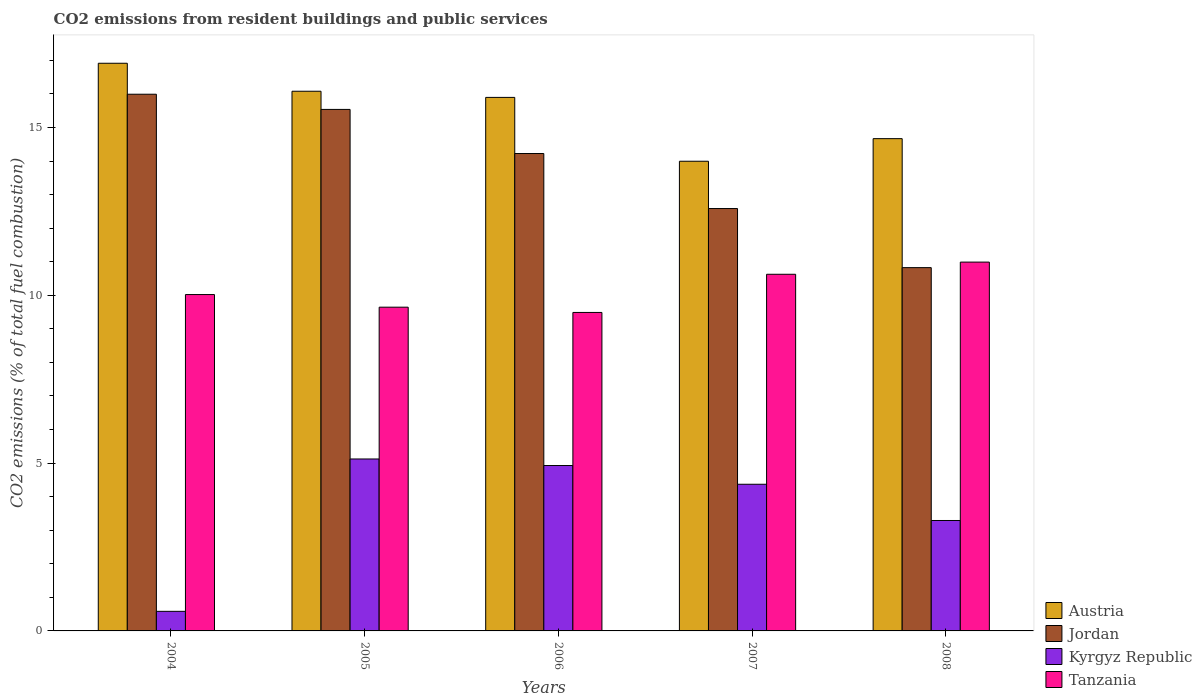How many groups of bars are there?
Keep it short and to the point. 5. How many bars are there on the 1st tick from the left?
Offer a very short reply. 4. How many bars are there on the 2nd tick from the right?
Keep it short and to the point. 4. What is the total CO2 emitted in Kyrgyz Republic in 2007?
Provide a succinct answer. 4.37. Across all years, what is the maximum total CO2 emitted in Kyrgyz Republic?
Make the answer very short. 5.12. Across all years, what is the minimum total CO2 emitted in Austria?
Your answer should be compact. 13.99. In which year was the total CO2 emitted in Kyrgyz Republic maximum?
Keep it short and to the point. 2005. In which year was the total CO2 emitted in Tanzania minimum?
Keep it short and to the point. 2006. What is the total total CO2 emitted in Kyrgyz Republic in the graph?
Give a very brief answer. 18.29. What is the difference between the total CO2 emitted in Austria in 2005 and that in 2007?
Make the answer very short. 2.09. What is the difference between the total CO2 emitted in Tanzania in 2007 and the total CO2 emitted in Austria in 2005?
Provide a succinct answer. -5.45. What is the average total CO2 emitted in Austria per year?
Provide a short and direct response. 15.51. In the year 2005, what is the difference between the total CO2 emitted in Jordan and total CO2 emitted in Tanzania?
Keep it short and to the point. 5.89. In how many years, is the total CO2 emitted in Jordan greater than 3?
Offer a terse response. 5. What is the ratio of the total CO2 emitted in Tanzania in 2004 to that in 2005?
Provide a short and direct response. 1.04. Is the total CO2 emitted in Jordan in 2004 less than that in 2006?
Your answer should be compact. No. Is the difference between the total CO2 emitted in Jordan in 2004 and 2008 greater than the difference between the total CO2 emitted in Tanzania in 2004 and 2008?
Your answer should be compact. Yes. What is the difference between the highest and the second highest total CO2 emitted in Tanzania?
Offer a very short reply. 0.36. What is the difference between the highest and the lowest total CO2 emitted in Tanzania?
Make the answer very short. 1.5. Is the sum of the total CO2 emitted in Jordan in 2005 and 2008 greater than the maximum total CO2 emitted in Tanzania across all years?
Ensure brevity in your answer.  Yes. Is it the case that in every year, the sum of the total CO2 emitted in Kyrgyz Republic and total CO2 emitted in Austria is greater than the sum of total CO2 emitted in Jordan and total CO2 emitted in Tanzania?
Your answer should be very brief. No. What does the 4th bar from the left in 2006 represents?
Give a very brief answer. Tanzania. What does the 2nd bar from the right in 2007 represents?
Provide a short and direct response. Kyrgyz Republic. Is it the case that in every year, the sum of the total CO2 emitted in Kyrgyz Republic and total CO2 emitted in Tanzania is greater than the total CO2 emitted in Austria?
Provide a succinct answer. No. How many bars are there?
Keep it short and to the point. 20. Are the values on the major ticks of Y-axis written in scientific E-notation?
Keep it short and to the point. No. Where does the legend appear in the graph?
Provide a succinct answer. Bottom right. What is the title of the graph?
Make the answer very short. CO2 emissions from resident buildings and public services. Does "Korea (Republic)" appear as one of the legend labels in the graph?
Your response must be concise. No. What is the label or title of the Y-axis?
Your answer should be compact. CO2 emissions (% of total fuel combustion). What is the CO2 emissions (% of total fuel combustion) in Austria in 2004?
Your answer should be compact. 16.91. What is the CO2 emissions (% of total fuel combustion) in Jordan in 2004?
Keep it short and to the point. 15.99. What is the CO2 emissions (% of total fuel combustion) in Kyrgyz Republic in 2004?
Provide a short and direct response. 0.58. What is the CO2 emissions (% of total fuel combustion) in Tanzania in 2004?
Provide a short and direct response. 10.02. What is the CO2 emissions (% of total fuel combustion) in Austria in 2005?
Offer a terse response. 16.08. What is the CO2 emissions (% of total fuel combustion) in Jordan in 2005?
Your answer should be compact. 15.54. What is the CO2 emissions (% of total fuel combustion) of Kyrgyz Republic in 2005?
Your answer should be compact. 5.12. What is the CO2 emissions (% of total fuel combustion) of Tanzania in 2005?
Offer a terse response. 9.65. What is the CO2 emissions (% of total fuel combustion) in Austria in 2006?
Make the answer very short. 15.9. What is the CO2 emissions (% of total fuel combustion) of Jordan in 2006?
Your answer should be compact. 14.22. What is the CO2 emissions (% of total fuel combustion) of Kyrgyz Republic in 2006?
Provide a succinct answer. 4.93. What is the CO2 emissions (% of total fuel combustion) in Tanzania in 2006?
Offer a very short reply. 9.49. What is the CO2 emissions (% of total fuel combustion) of Austria in 2007?
Keep it short and to the point. 13.99. What is the CO2 emissions (% of total fuel combustion) of Jordan in 2007?
Your answer should be very brief. 12.58. What is the CO2 emissions (% of total fuel combustion) of Kyrgyz Republic in 2007?
Ensure brevity in your answer.  4.37. What is the CO2 emissions (% of total fuel combustion) of Tanzania in 2007?
Your response must be concise. 10.63. What is the CO2 emissions (% of total fuel combustion) of Austria in 2008?
Give a very brief answer. 14.67. What is the CO2 emissions (% of total fuel combustion) of Jordan in 2008?
Provide a short and direct response. 10.82. What is the CO2 emissions (% of total fuel combustion) of Kyrgyz Republic in 2008?
Give a very brief answer. 3.29. What is the CO2 emissions (% of total fuel combustion) in Tanzania in 2008?
Provide a succinct answer. 10.99. Across all years, what is the maximum CO2 emissions (% of total fuel combustion) of Austria?
Your answer should be very brief. 16.91. Across all years, what is the maximum CO2 emissions (% of total fuel combustion) of Jordan?
Give a very brief answer. 15.99. Across all years, what is the maximum CO2 emissions (% of total fuel combustion) of Kyrgyz Republic?
Your answer should be compact. 5.12. Across all years, what is the maximum CO2 emissions (% of total fuel combustion) in Tanzania?
Your answer should be very brief. 10.99. Across all years, what is the minimum CO2 emissions (% of total fuel combustion) of Austria?
Give a very brief answer. 13.99. Across all years, what is the minimum CO2 emissions (% of total fuel combustion) of Jordan?
Keep it short and to the point. 10.82. Across all years, what is the minimum CO2 emissions (% of total fuel combustion) of Kyrgyz Republic?
Give a very brief answer. 0.58. Across all years, what is the minimum CO2 emissions (% of total fuel combustion) of Tanzania?
Your response must be concise. 9.49. What is the total CO2 emissions (% of total fuel combustion) in Austria in the graph?
Offer a very short reply. 77.55. What is the total CO2 emissions (% of total fuel combustion) of Jordan in the graph?
Keep it short and to the point. 69.16. What is the total CO2 emissions (% of total fuel combustion) in Kyrgyz Republic in the graph?
Make the answer very short. 18.29. What is the total CO2 emissions (% of total fuel combustion) in Tanzania in the graph?
Your answer should be very brief. 50.77. What is the difference between the CO2 emissions (% of total fuel combustion) in Austria in 2004 and that in 2005?
Offer a very short reply. 0.83. What is the difference between the CO2 emissions (% of total fuel combustion) in Jordan in 2004 and that in 2005?
Your answer should be compact. 0.45. What is the difference between the CO2 emissions (% of total fuel combustion) in Kyrgyz Republic in 2004 and that in 2005?
Your answer should be very brief. -4.54. What is the difference between the CO2 emissions (% of total fuel combustion) in Tanzania in 2004 and that in 2005?
Keep it short and to the point. 0.38. What is the difference between the CO2 emissions (% of total fuel combustion) of Austria in 2004 and that in 2006?
Your response must be concise. 1.02. What is the difference between the CO2 emissions (% of total fuel combustion) of Jordan in 2004 and that in 2006?
Your answer should be compact. 1.77. What is the difference between the CO2 emissions (% of total fuel combustion) in Kyrgyz Republic in 2004 and that in 2006?
Offer a terse response. -4.34. What is the difference between the CO2 emissions (% of total fuel combustion) of Tanzania in 2004 and that in 2006?
Make the answer very short. 0.53. What is the difference between the CO2 emissions (% of total fuel combustion) of Austria in 2004 and that in 2007?
Your response must be concise. 2.92. What is the difference between the CO2 emissions (% of total fuel combustion) of Jordan in 2004 and that in 2007?
Give a very brief answer. 3.41. What is the difference between the CO2 emissions (% of total fuel combustion) of Kyrgyz Republic in 2004 and that in 2007?
Ensure brevity in your answer.  -3.79. What is the difference between the CO2 emissions (% of total fuel combustion) in Tanzania in 2004 and that in 2007?
Provide a succinct answer. -0.6. What is the difference between the CO2 emissions (% of total fuel combustion) in Austria in 2004 and that in 2008?
Your response must be concise. 2.25. What is the difference between the CO2 emissions (% of total fuel combustion) of Jordan in 2004 and that in 2008?
Your answer should be very brief. 5.17. What is the difference between the CO2 emissions (% of total fuel combustion) in Kyrgyz Republic in 2004 and that in 2008?
Keep it short and to the point. -2.71. What is the difference between the CO2 emissions (% of total fuel combustion) in Tanzania in 2004 and that in 2008?
Your answer should be very brief. -0.97. What is the difference between the CO2 emissions (% of total fuel combustion) in Austria in 2005 and that in 2006?
Make the answer very short. 0.18. What is the difference between the CO2 emissions (% of total fuel combustion) of Jordan in 2005 and that in 2006?
Provide a succinct answer. 1.31. What is the difference between the CO2 emissions (% of total fuel combustion) in Kyrgyz Republic in 2005 and that in 2006?
Provide a succinct answer. 0.19. What is the difference between the CO2 emissions (% of total fuel combustion) of Tanzania in 2005 and that in 2006?
Keep it short and to the point. 0.16. What is the difference between the CO2 emissions (% of total fuel combustion) of Austria in 2005 and that in 2007?
Your answer should be compact. 2.09. What is the difference between the CO2 emissions (% of total fuel combustion) in Jordan in 2005 and that in 2007?
Your answer should be very brief. 2.95. What is the difference between the CO2 emissions (% of total fuel combustion) of Kyrgyz Republic in 2005 and that in 2007?
Provide a succinct answer. 0.75. What is the difference between the CO2 emissions (% of total fuel combustion) in Tanzania in 2005 and that in 2007?
Your answer should be compact. -0.98. What is the difference between the CO2 emissions (% of total fuel combustion) in Austria in 2005 and that in 2008?
Your answer should be compact. 1.41. What is the difference between the CO2 emissions (% of total fuel combustion) in Jordan in 2005 and that in 2008?
Make the answer very short. 4.71. What is the difference between the CO2 emissions (% of total fuel combustion) in Kyrgyz Republic in 2005 and that in 2008?
Provide a succinct answer. 1.83. What is the difference between the CO2 emissions (% of total fuel combustion) of Tanzania in 2005 and that in 2008?
Your answer should be very brief. -1.34. What is the difference between the CO2 emissions (% of total fuel combustion) in Austria in 2006 and that in 2007?
Provide a succinct answer. 1.9. What is the difference between the CO2 emissions (% of total fuel combustion) of Jordan in 2006 and that in 2007?
Make the answer very short. 1.64. What is the difference between the CO2 emissions (% of total fuel combustion) in Kyrgyz Republic in 2006 and that in 2007?
Your answer should be compact. 0.56. What is the difference between the CO2 emissions (% of total fuel combustion) of Tanzania in 2006 and that in 2007?
Give a very brief answer. -1.14. What is the difference between the CO2 emissions (% of total fuel combustion) in Austria in 2006 and that in 2008?
Your response must be concise. 1.23. What is the difference between the CO2 emissions (% of total fuel combustion) in Jordan in 2006 and that in 2008?
Provide a short and direct response. 3.4. What is the difference between the CO2 emissions (% of total fuel combustion) in Kyrgyz Republic in 2006 and that in 2008?
Your response must be concise. 1.64. What is the difference between the CO2 emissions (% of total fuel combustion) of Tanzania in 2006 and that in 2008?
Offer a very short reply. -1.5. What is the difference between the CO2 emissions (% of total fuel combustion) of Austria in 2007 and that in 2008?
Give a very brief answer. -0.67. What is the difference between the CO2 emissions (% of total fuel combustion) in Jordan in 2007 and that in 2008?
Make the answer very short. 1.76. What is the difference between the CO2 emissions (% of total fuel combustion) in Kyrgyz Republic in 2007 and that in 2008?
Ensure brevity in your answer.  1.08. What is the difference between the CO2 emissions (% of total fuel combustion) of Tanzania in 2007 and that in 2008?
Ensure brevity in your answer.  -0.36. What is the difference between the CO2 emissions (% of total fuel combustion) of Austria in 2004 and the CO2 emissions (% of total fuel combustion) of Jordan in 2005?
Offer a very short reply. 1.38. What is the difference between the CO2 emissions (% of total fuel combustion) of Austria in 2004 and the CO2 emissions (% of total fuel combustion) of Kyrgyz Republic in 2005?
Ensure brevity in your answer.  11.79. What is the difference between the CO2 emissions (% of total fuel combustion) in Austria in 2004 and the CO2 emissions (% of total fuel combustion) in Tanzania in 2005?
Give a very brief answer. 7.27. What is the difference between the CO2 emissions (% of total fuel combustion) of Jordan in 2004 and the CO2 emissions (% of total fuel combustion) of Kyrgyz Republic in 2005?
Keep it short and to the point. 10.87. What is the difference between the CO2 emissions (% of total fuel combustion) in Jordan in 2004 and the CO2 emissions (% of total fuel combustion) in Tanzania in 2005?
Offer a very short reply. 6.34. What is the difference between the CO2 emissions (% of total fuel combustion) of Kyrgyz Republic in 2004 and the CO2 emissions (% of total fuel combustion) of Tanzania in 2005?
Offer a very short reply. -9.06. What is the difference between the CO2 emissions (% of total fuel combustion) in Austria in 2004 and the CO2 emissions (% of total fuel combustion) in Jordan in 2006?
Offer a terse response. 2.69. What is the difference between the CO2 emissions (% of total fuel combustion) of Austria in 2004 and the CO2 emissions (% of total fuel combustion) of Kyrgyz Republic in 2006?
Keep it short and to the point. 11.99. What is the difference between the CO2 emissions (% of total fuel combustion) of Austria in 2004 and the CO2 emissions (% of total fuel combustion) of Tanzania in 2006?
Keep it short and to the point. 7.42. What is the difference between the CO2 emissions (% of total fuel combustion) of Jordan in 2004 and the CO2 emissions (% of total fuel combustion) of Kyrgyz Republic in 2006?
Your answer should be compact. 11.06. What is the difference between the CO2 emissions (% of total fuel combustion) in Jordan in 2004 and the CO2 emissions (% of total fuel combustion) in Tanzania in 2006?
Keep it short and to the point. 6.5. What is the difference between the CO2 emissions (% of total fuel combustion) in Kyrgyz Republic in 2004 and the CO2 emissions (% of total fuel combustion) in Tanzania in 2006?
Give a very brief answer. -8.91. What is the difference between the CO2 emissions (% of total fuel combustion) in Austria in 2004 and the CO2 emissions (% of total fuel combustion) in Jordan in 2007?
Make the answer very short. 4.33. What is the difference between the CO2 emissions (% of total fuel combustion) of Austria in 2004 and the CO2 emissions (% of total fuel combustion) of Kyrgyz Republic in 2007?
Your answer should be very brief. 12.54. What is the difference between the CO2 emissions (% of total fuel combustion) of Austria in 2004 and the CO2 emissions (% of total fuel combustion) of Tanzania in 2007?
Make the answer very short. 6.29. What is the difference between the CO2 emissions (% of total fuel combustion) of Jordan in 2004 and the CO2 emissions (% of total fuel combustion) of Kyrgyz Republic in 2007?
Give a very brief answer. 11.62. What is the difference between the CO2 emissions (% of total fuel combustion) of Jordan in 2004 and the CO2 emissions (% of total fuel combustion) of Tanzania in 2007?
Your answer should be compact. 5.36. What is the difference between the CO2 emissions (% of total fuel combustion) in Kyrgyz Republic in 2004 and the CO2 emissions (% of total fuel combustion) in Tanzania in 2007?
Provide a short and direct response. -10.04. What is the difference between the CO2 emissions (% of total fuel combustion) of Austria in 2004 and the CO2 emissions (% of total fuel combustion) of Jordan in 2008?
Ensure brevity in your answer.  6.09. What is the difference between the CO2 emissions (% of total fuel combustion) in Austria in 2004 and the CO2 emissions (% of total fuel combustion) in Kyrgyz Republic in 2008?
Give a very brief answer. 13.62. What is the difference between the CO2 emissions (% of total fuel combustion) in Austria in 2004 and the CO2 emissions (% of total fuel combustion) in Tanzania in 2008?
Provide a succinct answer. 5.92. What is the difference between the CO2 emissions (% of total fuel combustion) in Jordan in 2004 and the CO2 emissions (% of total fuel combustion) in Kyrgyz Republic in 2008?
Ensure brevity in your answer.  12.7. What is the difference between the CO2 emissions (% of total fuel combustion) in Jordan in 2004 and the CO2 emissions (% of total fuel combustion) in Tanzania in 2008?
Your response must be concise. 5. What is the difference between the CO2 emissions (% of total fuel combustion) in Kyrgyz Republic in 2004 and the CO2 emissions (% of total fuel combustion) in Tanzania in 2008?
Keep it short and to the point. -10.41. What is the difference between the CO2 emissions (% of total fuel combustion) in Austria in 2005 and the CO2 emissions (% of total fuel combustion) in Jordan in 2006?
Offer a very short reply. 1.86. What is the difference between the CO2 emissions (% of total fuel combustion) of Austria in 2005 and the CO2 emissions (% of total fuel combustion) of Kyrgyz Republic in 2006?
Make the answer very short. 11.15. What is the difference between the CO2 emissions (% of total fuel combustion) of Austria in 2005 and the CO2 emissions (% of total fuel combustion) of Tanzania in 2006?
Keep it short and to the point. 6.59. What is the difference between the CO2 emissions (% of total fuel combustion) of Jordan in 2005 and the CO2 emissions (% of total fuel combustion) of Kyrgyz Republic in 2006?
Your answer should be compact. 10.61. What is the difference between the CO2 emissions (% of total fuel combustion) in Jordan in 2005 and the CO2 emissions (% of total fuel combustion) in Tanzania in 2006?
Offer a terse response. 6.05. What is the difference between the CO2 emissions (% of total fuel combustion) of Kyrgyz Republic in 2005 and the CO2 emissions (% of total fuel combustion) of Tanzania in 2006?
Ensure brevity in your answer.  -4.37. What is the difference between the CO2 emissions (% of total fuel combustion) of Austria in 2005 and the CO2 emissions (% of total fuel combustion) of Jordan in 2007?
Ensure brevity in your answer.  3.49. What is the difference between the CO2 emissions (% of total fuel combustion) of Austria in 2005 and the CO2 emissions (% of total fuel combustion) of Kyrgyz Republic in 2007?
Provide a succinct answer. 11.71. What is the difference between the CO2 emissions (% of total fuel combustion) in Austria in 2005 and the CO2 emissions (% of total fuel combustion) in Tanzania in 2007?
Give a very brief answer. 5.45. What is the difference between the CO2 emissions (% of total fuel combustion) of Jordan in 2005 and the CO2 emissions (% of total fuel combustion) of Kyrgyz Republic in 2007?
Ensure brevity in your answer.  11.17. What is the difference between the CO2 emissions (% of total fuel combustion) of Jordan in 2005 and the CO2 emissions (% of total fuel combustion) of Tanzania in 2007?
Make the answer very short. 4.91. What is the difference between the CO2 emissions (% of total fuel combustion) in Kyrgyz Republic in 2005 and the CO2 emissions (% of total fuel combustion) in Tanzania in 2007?
Your answer should be compact. -5.5. What is the difference between the CO2 emissions (% of total fuel combustion) of Austria in 2005 and the CO2 emissions (% of total fuel combustion) of Jordan in 2008?
Offer a terse response. 5.26. What is the difference between the CO2 emissions (% of total fuel combustion) in Austria in 2005 and the CO2 emissions (% of total fuel combustion) in Kyrgyz Republic in 2008?
Provide a short and direct response. 12.79. What is the difference between the CO2 emissions (% of total fuel combustion) in Austria in 2005 and the CO2 emissions (% of total fuel combustion) in Tanzania in 2008?
Make the answer very short. 5.09. What is the difference between the CO2 emissions (% of total fuel combustion) in Jordan in 2005 and the CO2 emissions (% of total fuel combustion) in Kyrgyz Republic in 2008?
Offer a very short reply. 12.25. What is the difference between the CO2 emissions (% of total fuel combustion) in Jordan in 2005 and the CO2 emissions (% of total fuel combustion) in Tanzania in 2008?
Keep it short and to the point. 4.55. What is the difference between the CO2 emissions (% of total fuel combustion) in Kyrgyz Republic in 2005 and the CO2 emissions (% of total fuel combustion) in Tanzania in 2008?
Make the answer very short. -5.87. What is the difference between the CO2 emissions (% of total fuel combustion) of Austria in 2006 and the CO2 emissions (% of total fuel combustion) of Jordan in 2007?
Keep it short and to the point. 3.31. What is the difference between the CO2 emissions (% of total fuel combustion) of Austria in 2006 and the CO2 emissions (% of total fuel combustion) of Kyrgyz Republic in 2007?
Provide a short and direct response. 11.53. What is the difference between the CO2 emissions (% of total fuel combustion) in Austria in 2006 and the CO2 emissions (% of total fuel combustion) in Tanzania in 2007?
Ensure brevity in your answer.  5.27. What is the difference between the CO2 emissions (% of total fuel combustion) of Jordan in 2006 and the CO2 emissions (% of total fuel combustion) of Kyrgyz Republic in 2007?
Offer a very short reply. 9.85. What is the difference between the CO2 emissions (% of total fuel combustion) in Jordan in 2006 and the CO2 emissions (% of total fuel combustion) in Tanzania in 2007?
Offer a terse response. 3.6. What is the difference between the CO2 emissions (% of total fuel combustion) in Kyrgyz Republic in 2006 and the CO2 emissions (% of total fuel combustion) in Tanzania in 2007?
Provide a short and direct response. -5.7. What is the difference between the CO2 emissions (% of total fuel combustion) of Austria in 2006 and the CO2 emissions (% of total fuel combustion) of Jordan in 2008?
Your response must be concise. 5.07. What is the difference between the CO2 emissions (% of total fuel combustion) of Austria in 2006 and the CO2 emissions (% of total fuel combustion) of Kyrgyz Republic in 2008?
Ensure brevity in your answer.  12.61. What is the difference between the CO2 emissions (% of total fuel combustion) of Austria in 2006 and the CO2 emissions (% of total fuel combustion) of Tanzania in 2008?
Your answer should be very brief. 4.91. What is the difference between the CO2 emissions (% of total fuel combustion) of Jordan in 2006 and the CO2 emissions (% of total fuel combustion) of Kyrgyz Republic in 2008?
Offer a terse response. 10.93. What is the difference between the CO2 emissions (% of total fuel combustion) of Jordan in 2006 and the CO2 emissions (% of total fuel combustion) of Tanzania in 2008?
Your response must be concise. 3.23. What is the difference between the CO2 emissions (% of total fuel combustion) of Kyrgyz Republic in 2006 and the CO2 emissions (% of total fuel combustion) of Tanzania in 2008?
Keep it short and to the point. -6.06. What is the difference between the CO2 emissions (% of total fuel combustion) in Austria in 2007 and the CO2 emissions (% of total fuel combustion) in Jordan in 2008?
Ensure brevity in your answer.  3.17. What is the difference between the CO2 emissions (% of total fuel combustion) of Austria in 2007 and the CO2 emissions (% of total fuel combustion) of Kyrgyz Republic in 2008?
Offer a very short reply. 10.7. What is the difference between the CO2 emissions (% of total fuel combustion) in Austria in 2007 and the CO2 emissions (% of total fuel combustion) in Tanzania in 2008?
Your response must be concise. 3. What is the difference between the CO2 emissions (% of total fuel combustion) of Jordan in 2007 and the CO2 emissions (% of total fuel combustion) of Kyrgyz Republic in 2008?
Give a very brief answer. 9.29. What is the difference between the CO2 emissions (% of total fuel combustion) of Jordan in 2007 and the CO2 emissions (% of total fuel combustion) of Tanzania in 2008?
Offer a very short reply. 1.6. What is the difference between the CO2 emissions (% of total fuel combustion) of Kyrgyz Republic in 2007 and the CO2 emissions (% of total fuel combustion) of Tanzania in 2008?
Your answer should be very brief. -6.62. What is the average CO2 emissions (% of total fuel combustion) of Austria per year?
Make the answer very short. 15.51. What is the average CO2 emissions (% of total fuel combustion) of Jordan per year?
Give a very brief answer. 13.83. What is the average CO2 emissions (% of total fuel combustion) in Kyrgyz Republic per year?
Provide a short and direct response. 3.66. What is the average CO2 emissions (% of total fuel combustion) in Tanzania per year?
Provide a short and direct response. 10.15. In the year 2004, what is the difference between the CO2 emissions (% of total fuel combustion) of Austria and CO2 emissions (% of total fuel combustion) of Jordan?
Offer a terse response. 0.92. In the year 2004, what is the difference between the CO2 emissions (% of total fuel combustion) of Austria and CO2 emissions (% of total fuel combustion) of Kyrgyz Republic?
Offer a terse response. 16.33. In the year 2004, what is the difference between the CO2 emissions (% of total fuel combustion) of Austria and CO2 emissions (% of total fuel combustion) of Tanzania?
Make the answer very short. 6.89. In the year 2004, what is the difference between the CO2 emissions (% of total fuel combustion) of Jordan and CO2 emissions (% of total fuel combustion) of Kyrgyz Republic?
Your response must be concise. 15.41. In the year 2004, what is the difference between the CO2 emissions (% of total fuel combustion) of Jordan and CO2 emissions (% of total fuel combustion) of Tanzania?
Make the answer very short. 5.97. In the year 2004, what is the difference between the CO2 emissions (% of total fuel combustion) in Kyrgyz Republic and CO2 emissions (% of total fuel combustion) in Tanzania?
Provide a short and direct response. -9.44. In the year 2005, what is the difference between the CO2 emissions (% of total fuel combustion) in Austria and CO2 emissions (% of total fuel combustion) in Jordan?
Give a very brief answer. 0.54. In the year 2005, what is the difference between the CO2 emissions (% of total fuel combustion) in Austria and CO2 emissions (% of total fuel combustion) in Kyrgyz Republic?
Offer a terse response. 10.96. In the year 2005, what is the difference between the CO2 emissions (% of total fuel combustion) in Austria and CO2 emissions (% of total fuel combustion) in Tanzania?
Offer a very short reply. 6.43. In the year 2005, what is the difference between the CO2 emissions (% of total fuel combustion) in Jordan and CO2 emissions (% of total fuel combustion) in Kyrgyz Republic?
Give a very brief answer. 10.42. In the year 2005, what is the difference between the CO2 emissions (% of total fuel combustion) in Jordan and CO2 emissions (% of total fuel combustion) in Tanzania?
Provide a short and direct response. 5.89. In the year 2005, what is the difference between the CO2 emissions (% of total fuel combustion) of Kyrgyz Republic and CO2 emissions (% of total fuel combustion) of Tanzania?
Give a very brief answer. -4.52. In the year 2006, what is the difference between the CO2 emissions (% of total fuel combustion) in Austria and CO2 emissions (% of total fuel combustion) in Jordan?
Provide a succinct answer. 1.67. In the year 2006, what is the difference between the CO2 emissions (% of total fuel combustion) of Austria and CO2 emissions (% of total fuel combustion) of Kyrgyz Republic?
Offer a very short reply. 10.97. In the year 2006, what is the difference between the CO2 emissions (% of total fuel combustion) of Austria and CO2 emissions (% of total fuel combustion) of Tanzania?
Your answer should be very brief. 6.41. In the year 2006, what is the difference between the CO2 emissions (% of total fuel combustion) in Jordan and CO2 emissions (% of total fuel combustion) in Kyrgyz Republic?
Make the answer very short. 9.3. In the year 2006, what is the difference between the CO2 emissions (% of total fuel combustion) of Jordan and CO2 emissions (% of total fuel combustion) of Tanzania?
Offer a very short reply. 4.73. In the year 2006, what is the difference between the CO2 emissions (% of total fuel combustion) in Kyrgyz Republic and CO2 emissions (% of total fuel combustion) in Tanzania?
Your answer should be very brief. -4.56. In the year 2007, what is the difference between the CO2 emissions (% of total fuel combustion) of Austria and CO2 emissions (% of total fuel combustion) of Jordan?
Offer a very short reply. 1.41. In the year 2007, what is the difference between the CO2 emissions (% of total fuel combustion) of Austria and CO2 emissions (% of total fuel combustion) of Kyrgyz Republic?
Offer a terse response. 9.62. In the year 2007, what is the difference between the CO2 emissions (% of total fuel combustion) in Austria and CO2 emissions (% of total fuel combustion) in Tanzania?
Your answer should be very brief. 3.37. In the year 2007, what is the difference between the CO2 emissions (% of total fuel combustion) in Jordan and CO2 emissions (% of total fuel combustion) in Kyrgyz Republic?
Your answer should be compact. 8.21. In the year 2007, what is the difference between the CO2 emissions (% of total fuel combustion) in Jordan and CO2 emissions (% of total fuel combustion) in Tanzania?
Your answer should be compact. 1.96. In the year 2007, what is the difference between the CO2 emissions (% of total fuel combustion) in Kyrgyz Republic and CO2 emissions (% of total fuel combustion) in Tanzania?
Your answer should be compact. -6.26. In the year 2008, what is the difference between the CO2 emissions (% of total fuel combustion) of Austria and CO2 emissions (% of total fuel combustion) of Jordan?
Provide a succinct answer. 3.84. In the year 2008, what is the difference between the CO2 emissions (% of total fuel combustion) in Austria and CO2 emissions (% of total fuel combustion) in Kyrgyz Republic?
Ensure brevity in your answer.  11.38. In the year 2008, what is the difference between the CO2 emissions (% of total fuel combustion) of Austria and CO2 emissions (% of total fuel combustion) of Tanzania?
Make the answer very short. 3.68. In the year 2008, what is the difference between the CO2 emissions (% of total fuel combustion) of Jordan and CO2 emissions (% of total fuel combustion) of Kyrgyz Republic?
Offer a terse response. 7.53. In the year 2008, what is the difference between the CO2 emissions (% of total fuel combustion) of Jordan and CO2 emissions (% of total fuel combustion) of Tanzania?
Provide a succinct answer. -0.17. In the year 2008, what is the difference between the CO2 emissions (% of total fuel combustion) in Kyrgyz Republic and CO2 emissions (% of total fuel combustion) in Tanzania?
Your answer should be compact. -7.7. What is the ratio of the CO2 emissions (% of total fuel combustion) in Austria in 2004 to that in 2005?
Provide a short and direct response. 1.05. What is the ratio of the CO2 emissions (% of total fuel combustion) of Jordan in 2004 to that in 2005?
Offer a very short reply. 1.03. What is the ratio of the CO2 emissions (% of total fuel combustion) of Kyrgyz Republic in 2004 to that in 2005?
Your response must be concise. 0.11. What is the ratio of the CO2 emissions (% of total fuel combustion) of Tanzania in 2004 to that in 2005?
Provide a succinct answer. 1.04. What is the ratio of the CO2 emissions (% of total fuel combustion) of Austria in 2004 to that in 2006?
Provide a short and direct response. 1.06. What is the ratio of the CO2 emissions (% of total fuel combustion) in Jordan in 2004 to that in 2006?
Your answer should be compact. 1.12. What is the ratio of the CO2 emissions (% of total fuel combustion) in Kyrgyz Republic in 2004 to that in 2006?
Your response must be concise. 0.12. What is the ratio of the CO2 emissions (% of total fuel combustion) in Tanzania in 2004 to that in 2006?
Ensure brevity in your answer.  1.06. What is the ratio of the CO2 emissions (% of total fuel combustion) in Austria in 2004 to that in 2007?
Provide a succinct answer. 1.21. What is the ratio of the CO2 emissions (% of total fuel combustion) of Jordan in 2004 to that in 2007?
Make the answer very short. 1.27. What is the ratio of the CO2 emissions (% of total fuel combustion) of Kyrgyz Republic in 2004 to that in 2007?
Your response must be concise. 0.13. What is the ratio of the CO2 emissions (% of total fuel combustion) of Tanzania in 2004 to that in 2007?
Provide a succinct answer. 0.94. What is the ratio of the CO2 emissions (% of total fuel combustion) in Austria in 2004 to that in 2008?
Offer a very short reply. 1.15. What is the ratio of the CO2 emissions (% of total fuel combustion) of Jordan in 2004 to that in 2008?
Your answer should be compact. 1.48. What is the ratio of the CO2 emissions (% of total fuel combustion) of Kyrgyz Republic in 2004 to that in 2008?
Keep it short and to the point. 0.18. What is the ratio of the CO2 emissions (% of total fuel combustion) of Tanzania in 2004 to that in 2008?
Make the answer very short. 0.91. What is the ratio of the CO2 emissions (% of total fuel combustion) of Austria in 2005 to that in 2006?
Keep it short and to the point. 1.01. What is the ratio of the CO2 emissions (% of total fuel combustion) of Jordan in 2005 to that in 2006?
Your response must be concise. 1.09. What is the ratio of the CO2 emissions (% of total fuel combustion) of Kyrgyz Republic in 2005 to that in 2006?
Your answer should be compact. 1.04. What is the ratio of the CO2 emissions (% of total fuel combustion) of Tanzania in 2005 to that in 2006?
Make the answer very short. 1.02. What is the ratio of the CO2 emissions (% of total fuel combustion) in Austria in 2005 to that in 2007?
Give a very brief answer. 1.15. What is the ratio of the CO2 emissions (% of total fuel combustion) of Jordan in 2005 to that in 2007?
Give a very brief answer. 1.23. What is the ratio of the CO2 emissions (% of total fuel combustion) of Kyrgyz Republic in 2005 to that in 2007?
Offer a terse response. 1.17. What is the ratio of the CO2 emissions (% of total fuel combustion) in Tanzania in 2005 to that in 2007?
Offer a terse response. 0.91. What is the ratio of the CO2 emissions (% of total fuel combustion) of Austria in 2005 to that in 2008?
Your answer should be very brief. 1.1. What is the ratio of the CO2 emissions (% of total fuel combustion) in Jordan in 2005 to that in 2008?
Ensure brevity in your answer.  1.44. What is the ratio of the CO2 emissions (% of total fuel combustion) of Kyrgyz Republic in 2005 to that in 2008?
Offer a very short reply. 1.56. What is the ratio of the CO2 emissions (% of total fuel combustion) in Tanzania in 2005 to that in 2008?
Offer a very short reply. 0.88. What is the ratio of the CO2 emissions (% of total fuel combustion) in Austria in 2006 to that in 2007?
Your answer should be compact. 1.14. What is the ratio of the CO2 emissions (% of total fuel combustion) of Jordan in 2006 to that in 2007?
Your answer should be very brief. 1.13. What is the ratio of the CO2 emissions (% of total fuel combustion) in Kyrgyz Republic in 2006 to that in 2007?
Give a very brief answer. 1.13. What is the ratio of the CO2 emissions (% of total fuel combustion) of Tanzania in 2006 to that in 2007?
Provide a short and direct response. 0.89. What is the ratio of the CO2 emissions (% of total fuel combustion) of Austria in 2006 to that in 2008?
Ensure brevity in your answer.  1.08. What is the ratio of the CO2 emissions (% of total fuel combustion) of Jordan in 2006 to that in 2008?
Offer a very short reply. 1.31. What is the ratio of the CO2 emissions (% of total fuel combustion) of Kyrgyz Republic in 2006 to that in 2008?
Give a very brief answer. 1.5. What is the ratio of the CO2 emissions (% of total fuel combustion) in Tanzania in 2006 to that in 2008?
Give a very brief answer. 0.86. What is the ratio of the CO2 emissions (% of total fuel combustion) in Austria in 2007 to that in 2008?
Offer a very short reply. 0.95. What is the ratio of the CO2 emissions (% of total fuel combustion) in Jordan in 2007 to that in 2008?
Provide a short and direct response. 1.16. What is the ratio of the CO2 emissions (% of total fuel combustion) in Kyrgyz Republic in 2007 to that in 2008?
Your answer should be compact. 1.33. What is the ratio of the CO2 emissions (% of total fuel combustion) in Tanzania in 2007 to that in 2008?
Make the answer very short. 0.97. What is the difference between the highest and the second highest CO2 emissions (% of total fuel combustion) in Austria?
Provide a succinct answer. 0.83. What is the difference between the highest and the second highest CO2 emissions (% of total fuel combustion) in Jordan?
Provide a succinct answer. 0.45. What is the difference between the highest and the second highest CO2 emissions (% of total fuel combustion) of Kyrgyz Republic?
Offer a very short reply. 0.19. What is the difference between the highest and the second highest CO2 emissions (% of total fuel combustion) in Tanzania?
Provide a short and direct response. 0.36. What is the difference between the highest and the lowest CO2 emissions (% of total fuel combustion) in Austria?
Make the answer very short. 2.92. What is the difference between the highest and the lowest CO2 emissions (% of total fuel combustion) in Jordan?
Ensure brevity in your answer.  5.17. What is the difference between the highest and the lowest CO2 emissions (% of total fuel combustion) in Kyrgyz Republic?
Keep it short and to the point. 4.54. What is the difference between the highest and the lowest CO2 emissions (% of total fuel combustion) in Tanzania?
Your answer should be compact. 1.5. 